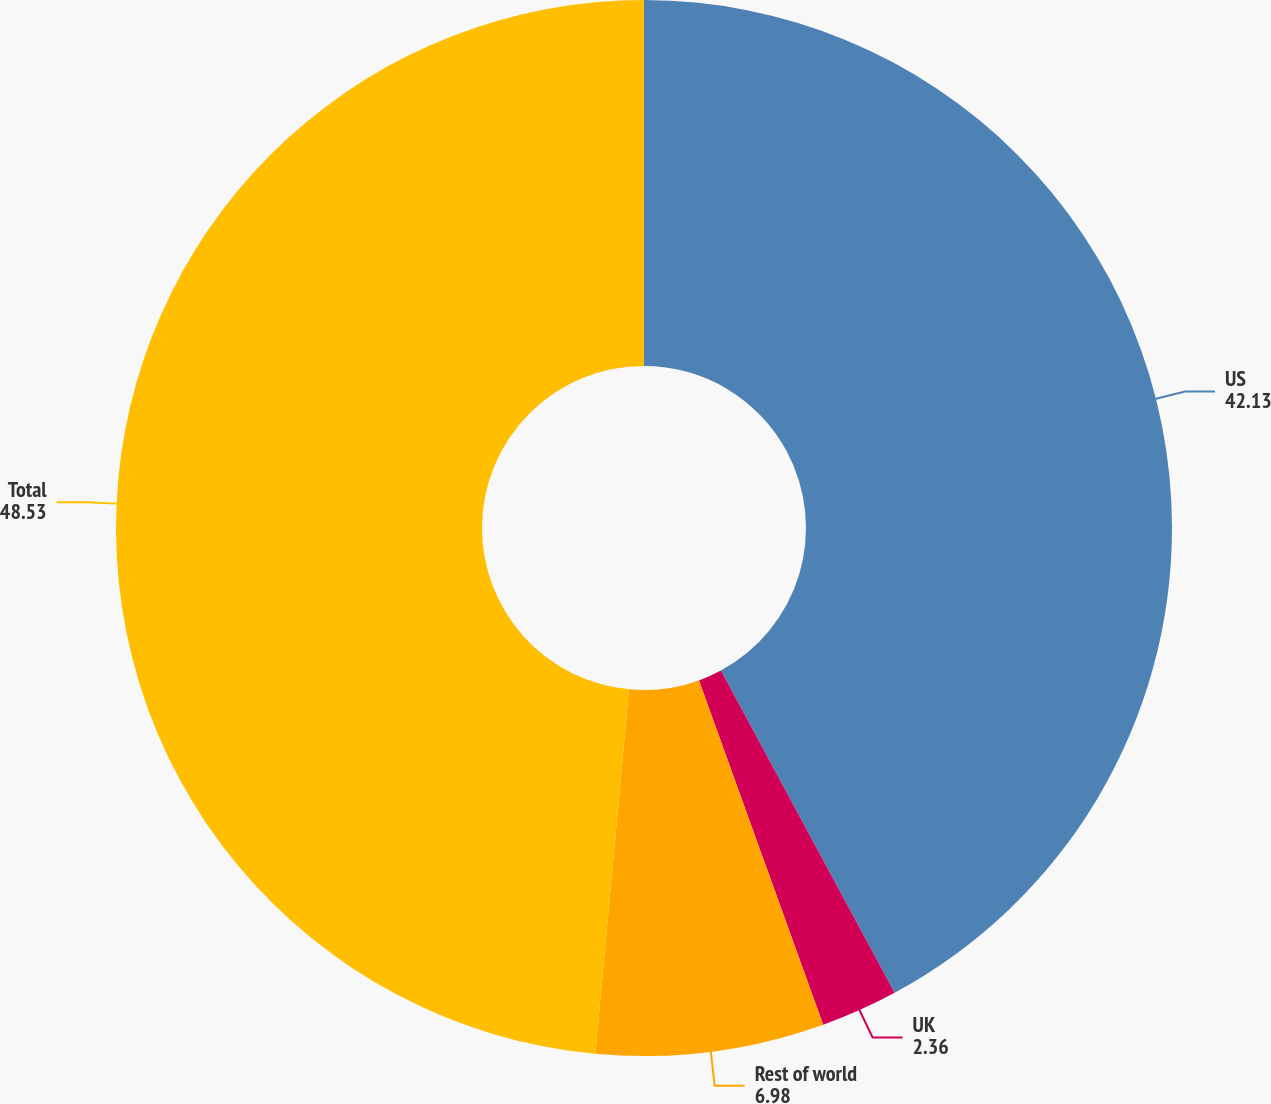<chart> <loc_0><loc_0><loc_500><loc_500><pie_chart><fcel>US<fcel>UK<fcel>Rest of world<fcel>Total<nl><fcel>42.13%<fcel>2.36%<fcel>6.98%<fcel>48.53%<nl></chart> 